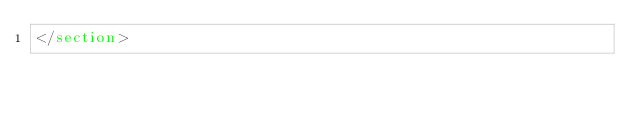<code> <loc_0><loc_0><loc_500><loc_500><_HTML_></section>
</code> 